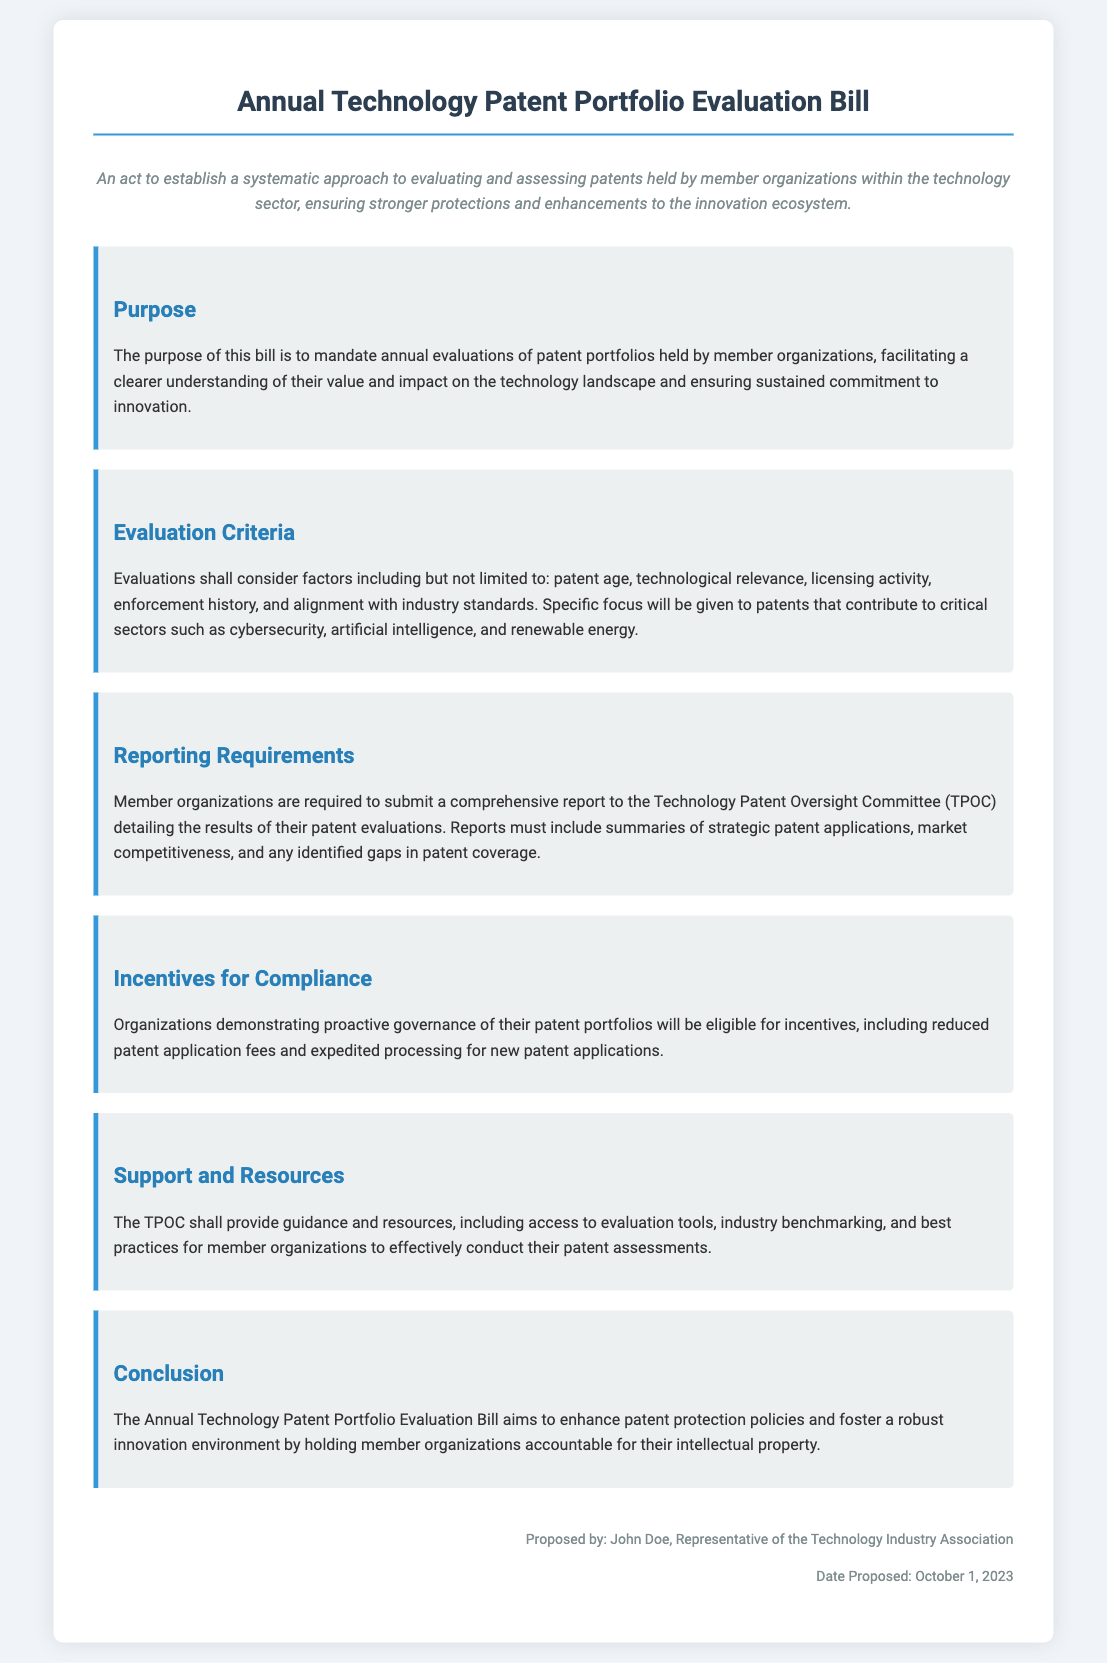What is the title of the bill? The title of the bill is stated at the top and indicates its primary subject matter.
Answer: Annual Technology Patent Portfolio Evaluation Bill Who proposed the bill? The document identifies the person responsible for proposing the bill in the footer.
Answer: John Doe What date was the bill proposed? The date of the proposal is included in the footer section of the document.
Answer: October 1, 2023 What committee receives the reports from member organizations? The committee responsible for receiving the evaluations is specified in the reporting requirements section.
Answer: Technology Patent Oversight Committee (TPOC) What is one factor considered in patent evaluations? The evaluation criteria mention specific factors that are taken into account for the assessments.
Answer: Patent age What type of patents will be given specific focus? The document specifies certain sectors that the evaluations will prioritize in the evaluation criteria.
Answer: Cybersecurity, artificial intelligence, and renewable energy What benefits do organizations receive for compliance? The incentives section outlines the benefits for organizations that effectively manage their patent portfolios.
Answer: Reduced patent application fees What is the purpose of the bill? The purpose of the bill is articulated in the designated section that outlines its objectives.
Answer: Mandate annual evaluations of patent portfolios How does the TPOC assist member organizations? The support and resources section explains how the TPOC aids organizations in their evaluation processes.
Answer: Guidance and resources 